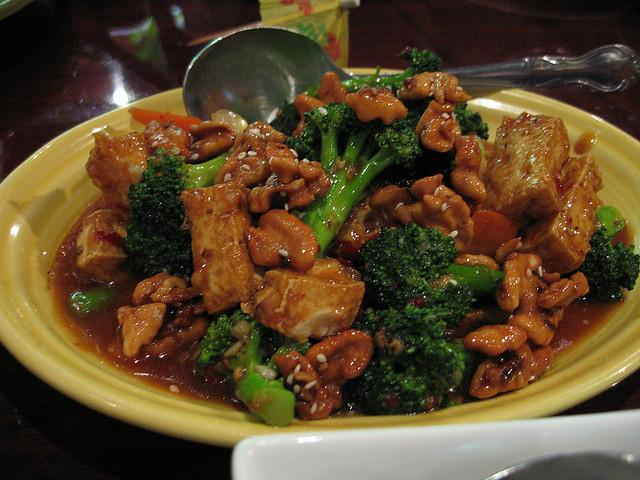What is the food covered in to make it orange? Please explain your reasoning. sauce. The food has sauce. 